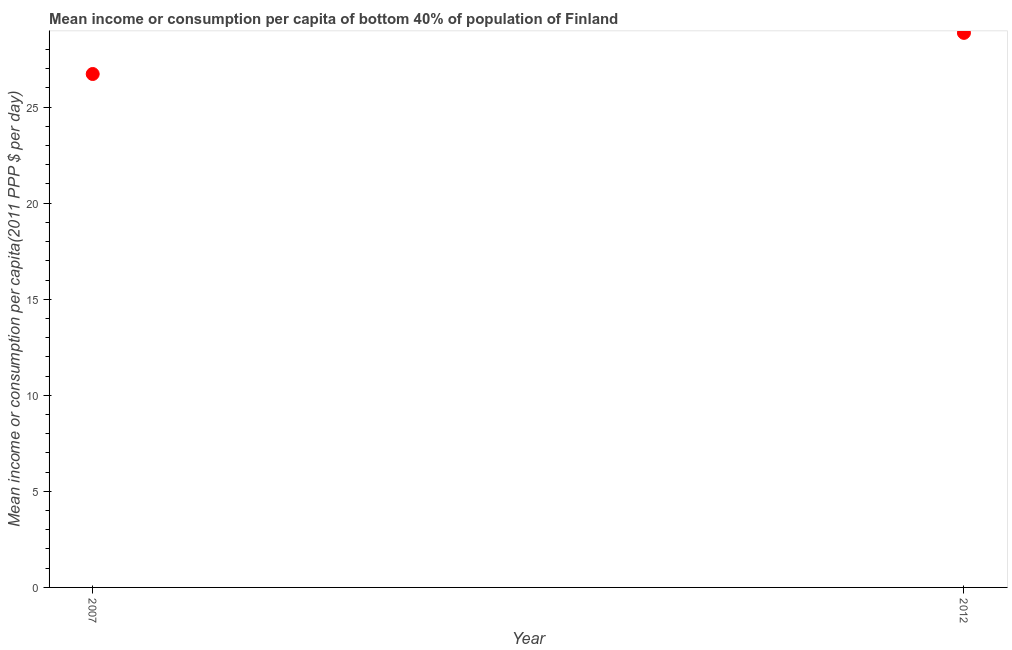What is the mean income or consumption in 2012?
Provide a short and direct response. 28.86. Across all years, what is the maximum mean income or consumption?
Offer a very short reply. 28.86. Across all years, what is the minimum mean income or consumption?
Provide a succinct answer. 26.72. In which year was the mean income or consumption maximum?
Ensure brevity in your answer.  2012. In which year was the mean income or consumption minimum?
Keep it short and to the point. 2007. What is the sum of the mean income or consumption?
Offer a terse response. 55.58. What is the difference between the mean income or consumption in 2007 and 2012?
Your answer should be compact. -2.14. What is the average mean income or consumption per year?
Offer a terse response. 27.79. What is the median mean income or consumption?
Your response must be concise. 27.79. In how many years, is the mean income or consumption greater than 18 $?
Ensure brevity in your answer.  2. Do a majority of the years between 2007 and 2012 (inclusive) have mean income or consumption greater than 9 $?
Give a very brief answer. Yes. What is the ratio of the mean income or consumption in 2007 to that in 2012?
Offer a very short reply. 0.93. Is the mean income or consumption in 2007 less than that in 2012?
Your response must be concise. Yes. Does the mean income or consumption monotonically increase over the years?
Your answer should be very brief. Yes. Are the values on the major ticks of Y-axis written in scientific E-notation?
Your answer should be very brief. No. Does the graph contain any zero values?
Provide a succinct answer. No. Does the graph contain grids?
Offer a terse response. No. What is the title of the graph?
Your answer should be very brief. Mean income or consumption per capita of bottom 40% of population of Finland. What is the label or title of the X-axis?
Give a very brief answer. Year. What is the label or title of the Y-axis?
Your response must be concise. Mean income or consumption per capita(2011 PPP $ per day). What is the Mean income or consumption per capita(2011 PPP $ per day) in 2007?
Provide a short and direct response. 26.72. What is the Mean income or consumption per capita(2011 PPP $ per day) in 2012?
Your answer should be very brief. 28.86. What is the difference between the Mean income or consumption per capita(2011 PPP $ per day) in 2007 and 2012?
Offer a very short reply. -2.14. What is the ratio of the Mean income or consumption per capita(2011 PPP $ per day) in 2007 to that in 2012?
Ensure brevity in your answer.  0.93. 